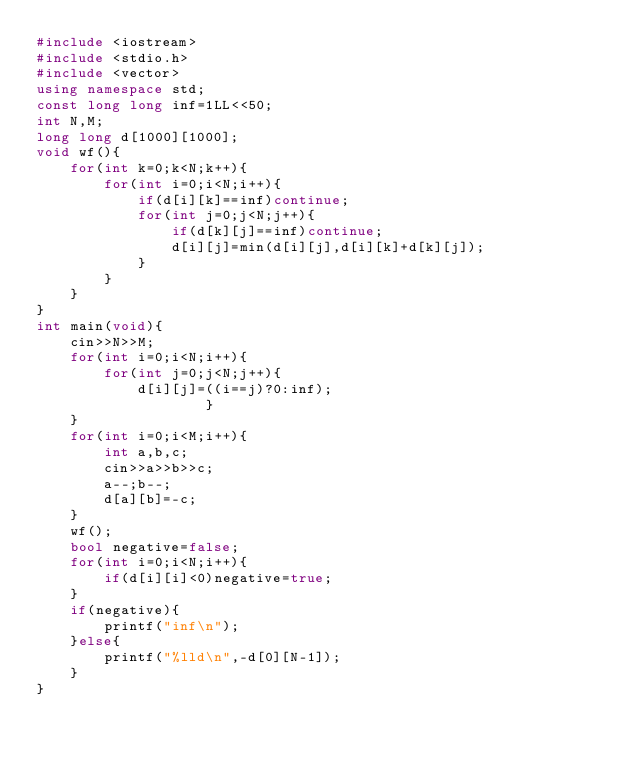<code> <loc_0><loc_0><loc_500><loc_500><_C++_>#include <iostream>
#include <stdio.h>
#include <vector>
using namespace std;
const long long inf=1LL<<50;
int N,M;
long long d[1000][1000];
void wf(){
    for(int k=0;k<N;k++){
        for(int i=0;i<N;i++){
            if(d[i][k]==inf)continue;
            for(int j=0;j<N;j++){
                if(d[k][j]==inf)continue;
                d[i][j]=min(d[i][j],d[i][k]+d[k][j]);
            }
        }
    }
}
int main(void){
    cin>>N>>M;
    for(int i=0;i<N;i++){
        for(int j=0;j<N;j++){
            d[i][j]=((i==j)?0:inf);
                    }
    }
    for(int i=0;i<M;i++){
        int a,b,c;
        cin>>a>>b>>c;
        a--;b--;
        d[a][b]=-c;
    }
    wf();
    bool negative=false;
    for(int i=0;i<N;i++){
        if(d[i][i]<0)negative=true;
    }
    if(negative){
        printf("inf\n");
    }else{
        printf("%lld\n",-d[0][N-1]);
    }
}</code> 